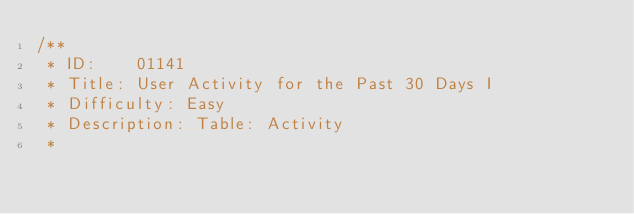Convert code to text. <code><loc_0><loc_0><loc_500><loc_500><_SQL_>/**
 * ID:    01141
 * Title: User Activity for the Past 30 Days I
 * Difficulty: Easy
 * Description: Table: Activity
 *</code> 